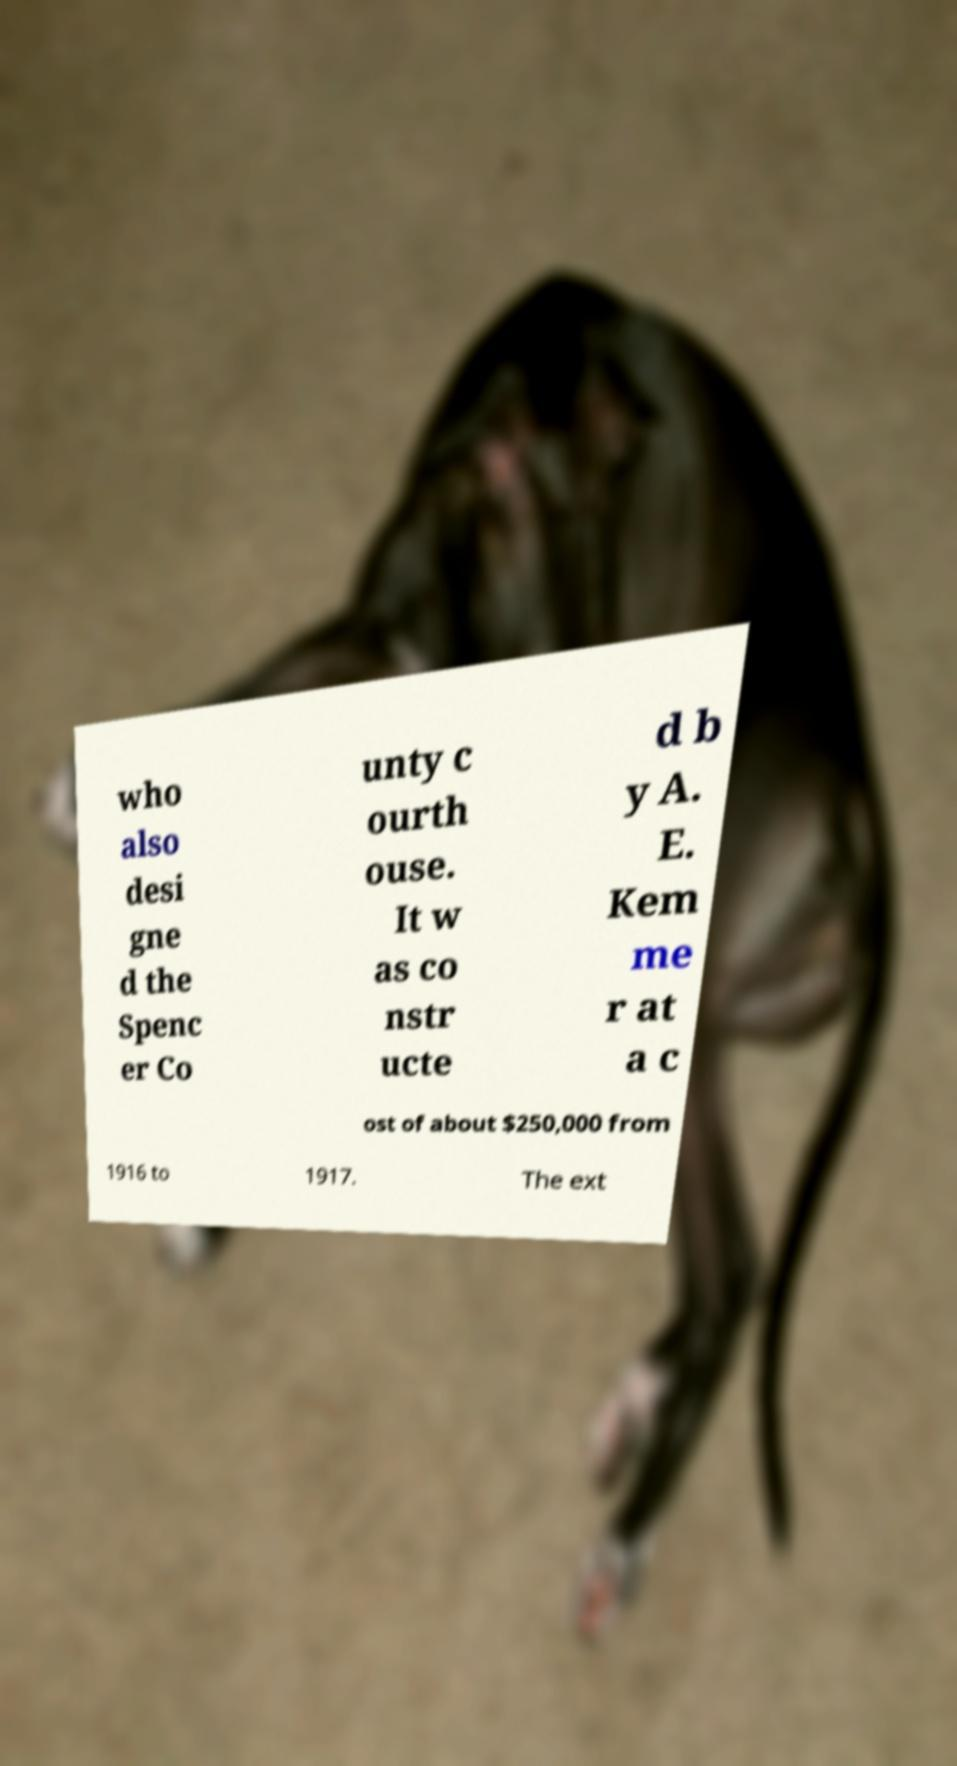Can you read and provide the text displayed in the image?This photo seems to have some interesting text. Can you extract and type it out for me? who also desi gne d the Spenc er Co unty c ourth ouse. It w as co nstr ucte d b y A. E. Kem me r at a c ost of about $250,000 from 1916 to 1917. The ext 